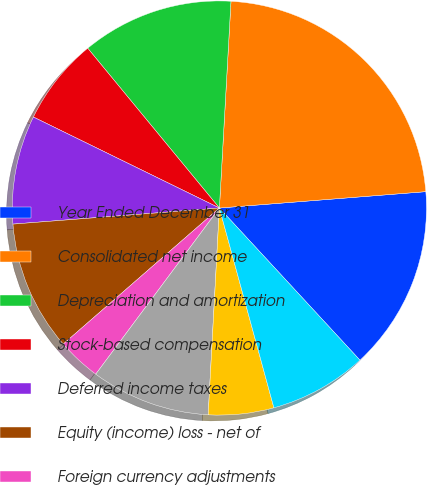Convert chart. <chart><loc_0><loc_0><loc_500><loc_500><pie_chart><fcel>Year Ended December 31<fcel>Consolidated net income<fcel>Depreciation and amortization<fcel>Stock-based compensation<fcel>Deferred income taxes<fcel>Equity (income) loss - net of<fcel>Foreign currency adjustments<fcel>Significant (gains) losses on<fcel>Other operating charges<fcel>Other items<nl><fcel>14.39%<fcel>22.85%<fcel>11.86%<fcel>6.79%<fcel>8.48%<fcel>10.17%<fcel>3.41%<fcel>9.32%<fcel>5.1%<fcel>7.63%<nl></chart> 